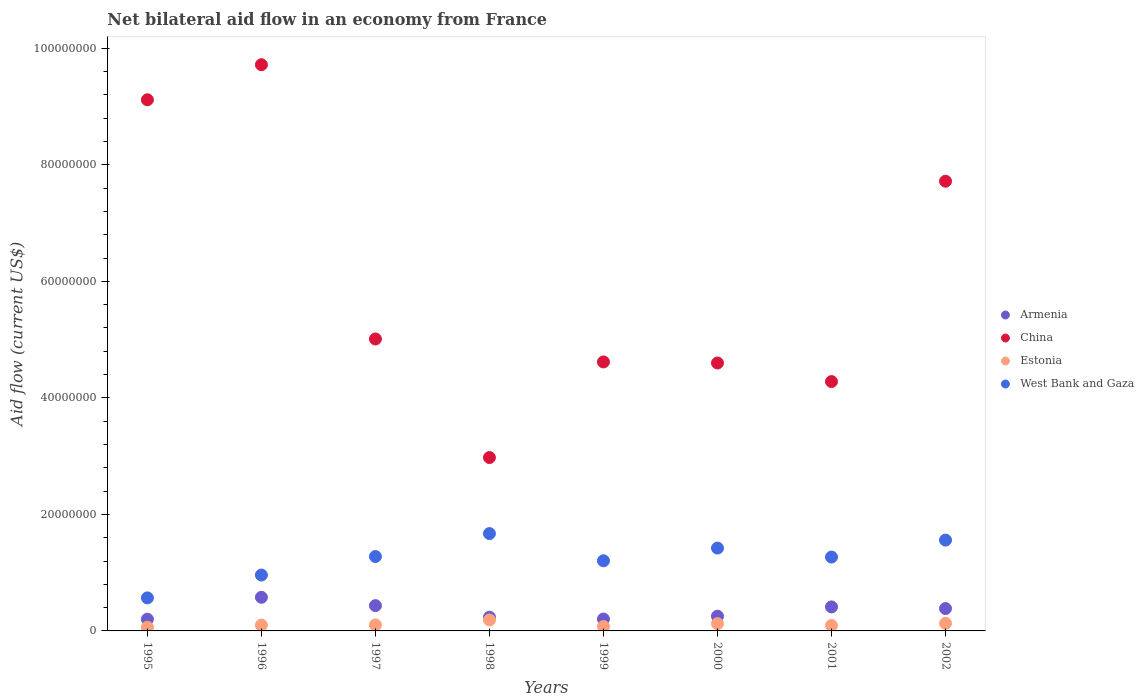How many different coloured dotlines are there?
Your answer should be very brief. 4. Is the number of dotlines equal to the number of legend labels?
Your answer should be very brief. Yes. What is the net bilateral aid flow in China in 1998?
Your answer should be very brief. 2.98e+07. Across all years, what is the maximum net bilateral aid flow in Estonia?
Your answer should be compact. 1.88e+06. Across all years, what is the minimum net bilateral aid flow in Armenia?
Give a very brief answer. 2.01e+06. In which year was the net bilateral aid flow in Armenia minimum?
Provide a short and direct response. 1995. What is the total net bilateral aid flow in Armenia in the graph?
Keep it short and to the point. 2.70e+07. What is the difference between the net bilateral aid flow in China in 1998 and that in 2001?
Offer a terse response. -1.30e+07. What is the difference between the net bilateral aid flow in West Bank and Gaza in 1995 and the net bilateral aid flow in China in 1999?
Keep it short and to the point. -4.05e+07. What is the average net bilateral aid flow in West Bank and Gaza per year?
Offer a terse response. 1.24e+07. In the year 1995, what is the difference between the net bilateral aid flow in West Bank and Gaza and net bilateral aid flow in Armenia?
Provide a short and direct response. 3.66e+06. What is the ratio of the net bilateral aid flow in Armenia in 1999 to that in 2002?
Offer a terse response. 0.53. Is the net bilateral aid flow in Armenia in 1999 less than that in 2002?
Offer a terse response. Yes. Is the difference between the net bilateral aid flow in West Bank and Gaza in 2000 and 2001 greater than the difference between the net bilateral aid flow in Armenia in 2000 and 2001?
Make the answer very short. Yes. What is the difference between the highest and the second highest net bilateral aid flow in China?
Your answer should be compact. 6.02e+06. What is the difference between the highest and the lowest net bilateral aid flow in West Bank and Gaza?
Your answer should be compact. 1.10e+07. Is it the case that in every year, the sum of the net bilateral aid flow in China and net bilateral aid flow in Estonia  is greater than the sum of net bilateral aid flow in Armenia and net bilateral aid flow in West Bank and Gaza?
Ensure brevity in your answer.  Yes. Is it the case that in every year, the sum of the net bilateral aid flow in Estonia and net bilateral aid flow in West Bank and Gaza  is greater than the net bilateral aid flow in China?
Make the answer very short. No. Is the net bilateral aid flow in Armenia strictly greater than the net bilateral aid flow in West Bank and Gaza over the years?
Your answer should be very brief. No. How many years are there in the graph?
Your answer should be very brief. 8. Are the values on the major ticks of Y-axis written in scientific E-notation?
Offer a terse response. No. Does the graph contain any zero values?
Your response must be concise. No. Does the graph contain grids?
Offer a terse response. No. How many legend labels are there?
Provide a succinct answer. 4. How are the legend labels stacked?
Your answer should be very brief. Vertical. What is the title of the graph?
Give a very brief answer. Net bilateral aid flow in an economy from France. What is the Aid flow (current US$) in Armenia in 1995?
Offer a terse response. 2.01e+06. What is the Aid flow (current US$) in China in 1995?
Make the answer very short. 9.12e+07. What is the Aid flow (current US$) of Estonia in 1995?
Provide a succinct answer. 6.30e+05. What is the Aid flow (current US$) of West Bank and Gaza in 1995?
Ensure brevity in your answer.  5.67e+06. What is the Aid flow (current US$) in Armenia in 1996?
Your response must be concise. 5.77e+06. What is the Aid flow (current US$) in China in 1996?
Give a very brief answer. 9.72e+07. What is the Aid flow (current US$) of West Bank and Gaza in 1996?
Make the answer very short. 9.59e+06. What is the Aid flow (current US$) of Armenia in 1997?
Your response must be concise. 4.34e+06. What is the Aid flow (current US$) of China in 1997?
Ensure brevity in your answer.  5.01e+07. What is the Aid flow (current US$) of Estonia in 1997?
Provide a succinct answer. 1.03e+06. What is the Aid flow (current US$) in West Bank and Gaza in 1997?
Make the answer very short. 1.28e+07. What is the Aid flow (current US$) of Armenia in 1998?
Your answer should be compact. 2.36e+06. What is the Aid flow (current US$) of China in 1998?
Provide a short and direct response. 2.98e+07. What is the Aid flow (current US$) in Estonia in 1998?
Offer a very short reply. 1.88e+06. What is the Aid flow (current US$) of West Bank and Gaza in 1998?
Ensure brevity in your answer.  1.67e+07. What is the Aid flow (current US$) in Armenia in 1999?
Keep it short and to the point. 2.04e+06. What is the Aid flow (current US$) of China in 1999?
Provide a short and direct response. 4.62e+07. What is the Aid flow (current US$) in Estonia in 1999?
Offer a terse response. 7.60e+05. What is the Aid flow (current US$) of West Bank and Gaza in 1999?
Keep it short and to the point. 1.20e+07. What is the Aid flow (current US$) of Armenia in 2000?
Offer a very short reply. 2.53e+06. What is the Aid flow (current US$) in China in 2000?
Your answer should be very brief. 4.60e+07. What is the Aid flow (current US$) of Estonia in 2000?
Provide a short and direct response. 1.25e+06. What is the Aid flow (current US$) in West Bank and Gaza in 2000?
Your answer should be compact. 1.42e+07. What is the Aid flow (current US$) of Armenia in 2001?
Your answer should be compact. 4.12e+06. What is the Aid flow (current US$) of China in 2001?
Provide a succinct answer. 4.28e+07. What is the Aid flow (current US$) in Estonia in 2001?
Your response must be concise. 9.40e+05. What is the Aid flow (current US$) in West Bank and Gaza in 2001?
Provide a succinct answer. 1.27e+07. What is the Aid flow (current US$) in Armenia in 2002?
Keep it short and to the point. 3.84e+06. What is the Aid flow (current US$) of China in 2002?
Provide a short and direct response. 7.72e+07. What is the Aid flow (current US$) of Estonia in 2002?
Your answer should be compact. 1.30e+06. What is the Aid flow (current US$) in West Bank and Gaza in 2002?
Your response must be concise. 1.56e+07. Across all years, what is the maximum Aid flow (current US$) in Armenia?
Your answer should be very brief. 5.77e+06. Across all years, what is the maximum Aid flow (current US$) in China?
Provide a succinct answer. 9.72e+07. Across all years, what is the maximum Aid flow (current US$) of Estonia?
Provide a succinct answer. 1.88e+06. Across all years, what is the maximum Aid flow (current US$) in West Bank and Gaza?
Keep it short and to the point. 1.67e+07. Across all years, what is the minimum Aid flow (current US$) of Armenia?
Offer a very short reply. 2.01e+06. Across all years, what is the minimum Aid flow (current US$) of China?
Keep it short and to the point. 2.98e+07. Across all years, what is the minimum Aid flow (current US$) in Estonia?
Offer a very short reply. 6.30e+05. Across all years, what is the minimum Aid flow (current US$) in West Bank and Gaza?
Your answer should be very brief. 5.67e+06. What is the total Aid flow (current US$) of Armenia in the graph?
Keep it short and to the point. 2.70e+07. What is the total Aid flow (current US$) of China in the graph?
Ensure brevity in your answer.  4.80e+08. What is the total Aid flow (current US$) of Estonia in the graph?
Your answer should be compact. 8.79e+06. What is the total Aid flow (current US$) in West Bank and Gaza in the graph?
Make the answer very short. 9.93e+07. What is the difference between the Aid flow (current US$) in Armenia in 1995 and that in 1996?
Ensure brevity in your answer.  -3.76e+06. What is the difference between the Aid flow (current US$) of China in 1995 and that in 1996?
Ensure brevity in your answer.  -6.02e+06. What is the difference between the Aid flow (current US$) in Estonia in 1995 and that in 1996?
Provide a succinct answer. -3.70e+05. What is the difference between the Aid flow (current US$) of West Bank and Gaza in 1995 and that in 1996?
Ensure brevity in your answer.  -3.92e+06. What is the difference between the Aid flow (current US$) of Armenia in 1995 and that in 1997?
Your response must be concise. -2.33e+06. What is the difference between the Aid flow (current US$) in China in 1995 and that in 1997?
Your answer should be very brief. 4.11e+07. What is the difference between the Aid flow (current US$) of Estonia in 1995 and that in 1997?
Offer a very short reply. -4.00e+05. What is the difference between the Aid flow (current US$) in West Bank and Gaza in 1995 and that in 1997?
Your response must be concise. -7.10e+06. What is the difference between the Aid flow (current US$) in Armenia in 1995 and that in 1998?
Your answer should be compact. -3.50e+05. What is the difference between the Aid flow (current US$) in China in 1995 and that in 1998?
Your answer should be very brief. 6.14e+07. What is the difference between the Aid flow (current US$) of Estonia in 1995 and that in 1998?
Your response must be concise. -1.25e+06. What is the difference between the Aid flow (current US$) in West Bank and Gaza in 1995 and that in 1998?
Offer a terse response. -1.10e+07. What is the difference between the Aid flow (current US$) in China in 1995 and that in 1999?
Give a very brief answer. 4.50e+07. What is the difference between the Aid flow (current US$) of Estonia in 1995 and that in 1999?
Ensure brevity in your answer.  -1.30e+05. What is the difference between the Aid flow (current US$) of West Bank and Gaza in 1995 and that in 1999?
Keep it short and to the point. -6.37e+06. What is the difference between the Aid flow (current US$) of Armenia in 1995 and that in 2000?
Provide a short and direct response. -5.20e+05. What is the difference between the Aid flow (current US$) of China in 1995 and that in 2000?
Ensure brevity in your answer.  4.52e+07. What is the difference between the Aid flow (current US$) in Estonia in 1995 and that in 2000?
Provide a short and direct response. -6.20e+05. What is the difference between the Aid flow (current US$) of West Bank and Gaza in 1995 and that in 2000?
Your response must be concise. -8.55e+06. What is the difference between the Aid flow (current US$) in Armenia in 1995 and that in 2001?
Your answer should be compact. -2.11e+06. What is the difference between the Aid flow (current US$) of China in 1995 and that in 2001?
Provide a short and direct response. 4.84e+07. What is the difference between the Aid flow (current US$) of Estonia in 1995 and that in 2001?
Your answer should be very brief. -3.10e+05. What is the difference between the Aid flow (current US$) in West Bank and Gaza in 1995 and that in 2001?
Your answer should be compact. -7.01e+06. What is the difference between the Aid flow (current US$) of Armenia in 1995 and that in 2002?
Offer a terse response. -1.83e+06. What is the difference between the Aid flow (current US$) of China in 1995 and that in 2002?
Offer a very short reply. 1.40e+07. What is the difference between the Aid flow (current US$) of Estonia in 1995 and that in 2002?
Provide a succinct answer. -6.70e+05. What is the difference between the Aid flow (current US$) in West Bank and Gaza in 1995 and that in 2002?
Your response must be concise. -9.92e+06. What is the difference between the Aid flow (current US$) in Armenia in 1996 and that in 1997?
Make the answer very short. 1.43e+06. What is the difference between the Aid flow (current US$) of China in 1996 and that in 1997?
Keep it short and to the point. 4.71e+07. What is the difference between the Aid flow (current US$) of West Bank and Gaza in 1996 and that in 1997?
Give a very brief answer. -3.18e+06. What is the difference between the Aid flow (current US$) of Armenia in 1996 and that in 1998?
Ensure brevity in your answer.  3.41e+06. What is the difference between the Aid flow (current US$) in China in 1996 and that in 1998?
Provide a short and direct response. 6.74e+07. What is the difference between the Aid flow (current US$) of Estonia in 1996 and that in 1998?
Your answer should be very brief. -8.80e+05. What is the difference between the Aid flow (current US$) in West Bank and Gaza in 1996 and that in 1998?
Provide a succinct answer. -7.12e+06. What is the difference between the Aid flow (current US$) of Armenia in 1996 and that in 1999?
Keep it short and to the point. 3.73e+06. What is the difference between the Aid flow (current US$) in China in 1996 and that in 1999?
Your answer should be compact. 5.10e+07. What is the difference between the Aid flow (current US$) in West Bank and Gaza in 1996 and that in 1999?
Your answer should be very brief. -2.45e+06. What is the difference between the Aid flow (current US$) in Armenia in 1996 and that in 2000?
Give a very brief answer. 3.24e+06. What is the difference between the Aid flow (current US$) of China in 1996 and that in 2000?
Give a very brief answer. 5.12e+07. What is the difference between the Aid flow (current US$) of West Bank and Gaza in 1996 and that in 2000?
Your answer should be compact. -4.63e+06. What is the difference between the Aid flow (current US$) of Armenia in 1996 and that in 2001?
Ensure brevity in your answer.  1.65e+06. What is the difference between the Aid flow (current US$) in China in 1996 and that in 2001?
Provide a short and direct response. 5.44e+07. What is the difference between the Aid flow (current US$) of West Bank and Gaza in 1996 and that in 2001?
Your answer should be very brief. -3.09e+06. What is the difference between the Aid flow (current US$) of Armenia in 1996 and that in 2002?
Provide a short and direct response. 1.93e+06. What is the difference between the Aid flow (current US$) in West Bank and Gaza in 1996 and that in 2002?
Give a very brief answer. -6.00e+06. What is the difference between the Aid flow (current US$) of Armenia in 1997 and that in 1998?
Make the answer very short. 1.98e+06. What is the difference between the Aid flow (current US$) in China in 1997 and that in 1998?
Your answer should be compact. 2.04e+07. What is the difference between the Aid flow (current US$) of Estonia in 1997 and that in 1998?
Provide a short and direct response. -8.50e+05. What is the difference between the Aid flow (current US$) in West Bank and Gaza in 1997 and that in 1998?
Offer a very short reply. -3.94e+06. What is the difference between the Aid flow (current US$) of Armenia in 1997 and that in 1999?
Your answer should be very brief. 2.30e+06. What is the difference between the Aid flow (current US$) in China in 1997 and that in 1999?
Your response must be concise. 3.94e+06. What is the difference between the Aid flow (current US$) of West Bank and Gaza in 1997 and that in 1999?
Offer a terse response. 7.30e+05. What is the difference between the Aid flow (current US$) of Armenia in 1997 and that in 2000?
Offer a very short reply. 1.81e+06. What is the difference between the Aid flow (current US$) of China in 1997 and that in 2000?
Give a very brief answer. 4.12e+06. What is the difference between the Aid flow (current US$) in West Bank and Gaza in 1997 and that in 2000?
Provide a short and direct response. -1.45e+06. What is the difference between the Aid flow (current US$) of China in 1997 and that in 2001?
Your response must be concise. 7.31e+06. What is the difference between the Aid flow (current US$) of Estonia in 1997 and that in 2001?
Provide a succinct answer. 9.00e+04. What is the difference between the Aid flow (current US$) in China in 1997 and that in 2002?
Your answer should be compact. -2.71e+07. What is the difference between the Aid flow (current US$) of Estonia in 1997 and that in 2002?
Offer a terse response. -2.70e+05. What is the difference between the Aid flow (current US$) of West Bank and Gaza in 1997 and that in 2002?
Offer a very short reply. -2.82e+06. What is the difference between the Aid flow (current US$) in Armenia in 1998 and that in 1999?
Your answer should be very brief. 3.20e+05. What is the difference between the Aid flow (current US$) in China in 1998 and that in 1999?
Provide a succinct answer. -1.64e+07. What is the difference between the Aid flow (current US$) of Estonia in 1998 and that in 1999?
Provide a short and direct response. 1.12e+06. What is the difference between the Aid flow (current US$) of West Bank and Gaza in 1998 and that in 1999?
Offer a terse response. 4.67e+06. What is the difference between the Aid flow (current US$) in Armenia in 1998 and that in 2000?
Provide a short and direct response. -1.70e+05. What is the difference between the Aid flow (current US$) of China in 1998 and that in 2000?
Offer a very short reply. -1.62e+07. What is the difference between the Aid flow (current US$) in Estonia in 1998 and that in 2000?
Your answer should be compact. 6.30e+05. What is the difference between the Aid flow (current US$) of West Bank and Gaza in 1998 and that in 2000?
Offer a terse response. 2.49e+06. What is the difference between the Aid flow (current US$) of Armenia in 1998 and that in 2001?
Your answer should be very brief. -1.76e+06. What is the difference between the Aid flow (current US$) of China in 1998 and that in 2001?
Keep it short and to the point. -1.30e+07. What is the difference between the Aid flow (current US$) in Estonia in 1998 and that in 2001?
Your response must be concise. 9.40e+05. What is the difference between the Aid flow (current US$) of West Bank and Gaza in 1998 and that in 2001?
Your answer should be compact. 4.03e+06. What is the difference between the Aid flow (current US$) in Armenia in 1998 and that in 2002?
Your answer should be compact. -1.48e+06. What is the difference between the Aid flow (current US$) of China in 1998 and that in 2002?
Your answer should be compact. -4.74e+07. What is the difference between the Aid flow (current US$) in Estonia in 1998 and that in 2002?
Your answer should be compact. 5.80e+05. What is the difference between the Aid flow (current US$) of West Bank and Gaza in 1998 and that in 2002?
Your response must be concise. 1.12e+06. What is the difference between the Aid flow (current US$) in Armenia in 1999 and that in 2000?
Make the answer very short. -4.90e+05. What is the difference between the Aid flow (current US$) in China in 1999 and that in 2000?
Your answer should be compact. 1.80e+05. What is the difference between the Aid flow (current US$) of Estonia in 1999 and that in 2000?
Ensure brevity in your answer.  -4.90e+05. What is the difference between the Aid flow (current US$) in West Bank and Gaza in 1999 and that in 2000?
Your response must be concise. -2.18e+06. What is the difference between the Aid flow (current US$) in Armenia in 1999 and that in 2001?
Offer a terse response. -2.08e+06. What is the difference between the Aid flow (current US$) in China in 1999 and that in 2001?
Offer a very short reply. 3.37e+06. What is the difference between the Aid flow (current US$) of Estonia in 1999 and that in 2001?
Your answer should be compact. -1.80e+05. What is the difference between the Aid flow (current US$) of West Bank and Gaza in 1999 and that in 2001?
Your answer should be compact. -6.40e+05. What is the difference between the Aid flow (current US$) of Armenia in 1999 and that in 2002?
Offer a terse response. -1.80e+06. What is the difference between the Aid flow (current US$) of China in 1999 and that in 2002?
Offer a very short reply. -3.10e+07. What is the difference between the Aid flow (current US$) in Estonia in 1999 and that in 2002?
Offer a very short reply. -5.40e+05. What is the difference between the Aid flow (current US$) of West Bank and Gaza in 1999 and that in 2002?
Ensure brevity in your answer.  -3.55e+06. What is the difference between the Aid flow (current US$) in Armenia in 2000 and that in 2001?
Provide a short and direct response. -1.59e+06. What is the difference between the Aid flow (current US$) in China in 2000 and that in 2001?
Your response must be concise. 3.19e+06. What is the difference between the Aid flow (current US$) in West Bank and Gaza in 2000 and that in 2001?
Offer a very short reply. 1.54e+06. What is the difference between the Aid flow (current US$) of Armenia in 2000 and that in 2002?
Provide a succinct answer. -1.31e+06. What is the difference between the Aid flow (current US$) in China in 2000 and that in 2002?
Give a very brief answer. -3.12e+07. What is the difference between the Aid flow (current US$) of West Bank and Gaza in 2000 and that in 2002?
Your response must be concise. -1.37e+06. What is the difference between the Aid flow (current US$) of Armenia in 2001 and that in 2002?
Ensure brevity in your answer.  2.80e+05. What is the difference between the Aid flow (current US$) in China in 2001 and that in 2002?
Keep it short and to the point. -3.44e+07. What is the difference between the Aid flow (current US$) of Estonia in 2001 and that in 2002?
Make the answer very short. -3.60e+05. What is the difference between the Aid flow (current US$) in West Bank and Gaza in 2001 and that in 2002?
Ensure brevity in your answer.  -2.91e+06. What is the difference between the Aid flow (current US$) of Armenia in 1995 and the Aid flow (current US$) of China in 1996?
Your response must be concise. -9.52e+07. What is the difference between the Aid flow (current US$) of Armenia in 1995 and the Aid flow (current US$) of Estonia in 1996?
Your answer should be compact. 1.01e+06. What is the difference between the Aid flow (current US$) of Armenia in 1995 and the Aid flow (current US$) of West Bank and Gaza in 1996?
Your answer should be compact. -7.58e+06. What is the difference between the Aid flow (current US$) of China in 1995 and the Aid flow (current US$) of Estonia in 1996?
Your response must be concise. 9.02e+07. What is the difference between the Aid flow (current US$) of China in 1995 and the Aid flow (current US$) of West Bank and Gaza in 1996?
Provide a succinct answer. 8.16e+07. What is the difference between the Aid flow (current US$) of Estonia in 1995 and the Aid flow (current US$) of West Bank and Gaza in 1996?
Keep it short and to the point. -8.96e+06. What is the difference between the Aid flow (current US$) of Armenia in 1995 and the Aid flow (current US$) of China in 1997?
Ensure brevity in your answer.  -4.81e+07. What is the difference between the Aid flow (current US$) of Armenia in 1995 and the Aid flow (current US$) of Estonia in 1997?
Your answer should be compact. 9.80e+05. What is the difference between the Aid flow (current US$) of Armenia in 1995 and the Aid flow (current US$) of West Bank and Gaza in 1997?
Your answer should be compact. -1.08e+07. What is the difference between the Aid flow (current US$) in China in 1995 and the Aid flow (current US$) in Estonia in 1997?
Provide a short and direct response. 9.01e+07. What is the difference between the Aid flow (current US$) of China in 1995 and the Aid flow (current US$) of West Bank and Gaza in 1997?
Keep it short and to the point. 7.84e+07. What is the difference between the Aid flow (current US$) of Estonia in 1995 and the Aid flow (current US$) of West Bank and Gaza in 1997?
Give a very brief answer. -1.21e+07. What is the difference between the Aid flow (current US$) in Armenia in 1995 and the Aid flow (current US$) in China in 1998?
Make the answer very short. -2.78e+07. What is the difference between the Aid flow (current US$) of Armenia in 1995 and the Aid flow (current US$) of Estonia in 1998?
Offer a terse response. 1.30e+05. What is the difference between the Aid flow (current US$) of Armenia in 1995 and the Aid flow (current US$) of West Bank and Gaza in 1998?
Make the answer very short. -1.47e+07. What is the difference between the Aid flow (current US$) of China in 1995 and the Aid flow (current US$) of Estonia in 1998?
Your answer should be very brief. 8.93e+07. What is the difference between the Aid flow (current US$) of China in 1995 and the Aid flow (current US$) of West Bank and Gaza in 1998?
Ensure brevity in your answer.  7.45e+07. What is the difference between the Aid flow (current US$) in Estonia in 1995 and the Aid flow (current US$) in West Bank and Gaza in 1998?
Make the answer very short. -1.61e+07. What is the difference between the Aid flow (current US$) in Armenia in 1995 and the Aid flow (current US$) in China in 1999?
Provide a short and direct response. -4.42e+07. What is the difference between the Aid flow (current US$) of Armenia in 1995 and the Aid flow (current US$) of Estonia in 1999?
Your response must be concise. 1.25e+06. What is the difference between the Aid flow (current US$) of Armenia in 1995 and the Aid flow (current US$) of West Bank and Gaza in 1999?
Give a very brief answer. -1.00e+07. What is the difference between the Aid flow (current US$) of China in 1995 and the Aid flow (current US$) of Estonia in 1999?
Ensure brevity in your answer.  9.04e+07. What is the difference between the Aid flow (current US$) in China in 1995 and the Aid flow (current US$) in West Bank and Gaza in 1999?
Ensure brevity in your answer.  7.91e+07. What is the difference between the Aid flow (current US$) of Estonia in 1995 and the Aid flow (current US$) of West Bank and Gaza in 1999?
Offer a very short reply. -1.14e+07. What is the difference between the Aid flow (current US$) in Armenia in 1995 and the Aid flow (current US$) in China in 2000?
Your response must be concise. -4.40e+07. What is the difference between the Aid flow (current US$) of Armenia in 1995 and the Aid flow (current US$) of Estonia in 2000?
Your answer should be compact. 7.60e+05. What is the difference between the Aid flow (current US$) in Armenia in 1995 and the Aid flow (current US$) in West Bank and Gaza in 2000?
Your response must be concise. -1.22e+07. What is the difference between the Aid flow (current US$) of China in 1995 and the Aid flow (current US$) of Estonia in 2000?
Keep it short and to the point. 8.99e+07. What is the difference between the Aid flow (current US$) of China in 1995 and the Aid flow (current US$) of West Bank and Gaza in 2000?
Ensure brevity in your answer.  7.70e+07. What is the difference between the Aid flow (current US$) in Estonia in 1995 and the Aid flow (current US$) in West Bank and Gaza in 2000?
Your answer should be compact. -1.36e+07. What is the difference between the Aid flow (current US$) of Armenia in 1995 and the Aid flow (current US$) of China in 2001?
Provide a succinct answer. -4.08e+07. What is the difference between the Aid flow (current US$) in Armenia in 1995 and the Aid flow (current US$) in Estonia in 2001?
Offer a very short reply. 1.07e+06. What is the difference between the Aid flow (current US$) in Armenia in 1995 and the Aid flow (current US$) in West Bank and Gaza in 2001?
Make the answer very short. -1.07e+07. What is the difference between the Aid flow (current US$) in China in 1995 and the Aid flow (current US$) in Estonia in 2001?
Provide a short and direct response. 9.02e+07. What is the difference between the Aid flow (current US$) in China in 1995 and the Aid flow (current US$) in West Bank and Gaza in 2001?
Offer a terse response. 7.85e+07. What is the difference between the Aid flow (current US$) of Estonia in 1995 and the Aid flow (current US$) of West Bank and Gaza in 2001?
Make the answer very short. -1.20e+07. What is the difference between the Aid flow (current US$) in Armenia in 1995 and the Aid flow (current US$) in China in 2002?
Provide a short and direct response. -7.52e+07. What is the difference between the Aid flow (current US$) in Armenia in 1995 and the Aid flow (current US$) in Estonia in 2002?
Give a very brief answer. 7.10e+05. What is the difference between the Aid flow (current US$) of Armenia in 1995 and the Aid flow (current US$) of West Bank and Gaza in 2002?
Provide a succinct answer. -1.36e+07. What is the difference between the Aid flow (current US$) in China in 1995 and the Aid flow (current US$) in Estonia in 2002?
Your answer should be very brief. 8.99e+07. What is the difference between the Aid flow (current US$) in China in 1995 and the Aid flow (current US$) in West Bank and Gaza in 2002?
Your answer should be very brief. 7.56e+07. What is the difference between the Aid flow (current US$) in Estonia in 1995 and the Aid flow (current US$) in West Bank and Gaza in 2002?
Provide a succinct answer. -1.50e+07. What is the difference between the Aid flow (current US$) of Armenia in 1996 and the Aid flow (current US$) of China in 1997?
Your answer should be compact. -4.43e+07. What is the difference between the Aid flow (current US$) of Armenia in 1996 and the Aid flow (current US$) of Estonia in 1997?
Ensure brevity in your answer.  4.74e+06. What is the difference between the Aid flow (current US$) in Armenia in 1996 and the Aid flow (current US$) in West Bank and Gaza in 1997?
Ensure brevity in your answer.  -7.00e+06. What is the difference between the Aid flow (current US$) of China in 1996 and the Aid flow (current US$) of Estonia in 1997?
Offer a very short reply. 9.62e+07. What is the difference between the Aid flow (current US$) in China in 1996 and the Aid flow (current US$) in West Bank and Gaza in 1997?
Give a very brief answer. 8.44e+07. What is the difference between the Aid flow (current US$) of Estonia in 1996 and the Aid flow (current US$) of West Bank and Gaza in 1997?
Give a very brief answer. -1.18e+07. What is the difference between the Aid flow (current US$) of Armenia in 1996 and the Aid flow (current US$) of China in 1998?
Your response must be concise. -2.40e+07. What is the difference between the Aid flow (current US$) in Armenia in 1996 and the Aid flow (current US$) in Estonia in 1998?
Give a very brief answer. 3.89e+06. What is the difference between the Aid flow (current US$) in Armenia in 1996 and the Aid flow (current US$) in West Bank and Gaza in 1998?
Your answer should be compact. -1.09e+07. What is the difference between the Aid flow (current US$) of China in 1996 and the Aid flow (current US$) of Estonia in 1998?
Offer a terse response. 9.53e+07. What is the difference between the Aid flow (current US$) in China in 1996 and the Aid flow (current US$) in West Bank and Gaza in 1998?
Keep it short and to the point. 8.05e+07. What is the difference between the Aid flow (current US$) in Estonia in 1996 and the Aid flow (current US$) in West Bank and Gaza in 1998?
Offer a very short reply. -1.57e+07. What is the difference between the Aid flow (current US$) in Armenia in 1996 and the Aid flow (current US$) in China in 1999?
Your response must be concise. -4.04e+07. What is the difference between the Aid flow (current US$) in Armenia in 1996 and the Aid flow (current US$) in Estonia in 1999?
Your answer should be compact. 5.01e+06. What is the difference between the Aid flow (current US$) in Armenia in 1996 and the Aid flow (current US$) in West Bank and Gaza in 1999?
Your response must be concise. -6.27e+06. What is the difference between the Aid flow (current US$) in China in 1996 and the Aid flow (current US$) in Estonia in 1999?
Make the answer very short. 9.64e+07. What is the difference between the Aid flow (current US$) in China in 1996 and the Aid flow (current US$) in West Bank and Gaza in 1999?
Offer a terse response. 8.52e+07. What is the difference between the Aid flow (current US$) in Estonia in 1996 and the Aid flow (current US$) in West Bank and Gaza in 1999?
Offer a very short reply. -1.10e+07. What is the difference between the Aid flow (current US$) in Armenia in 1996 and the Aid flow (current US$) in China in 2000?
Offer a very short reply. -4.02e+07. What is the difference between the Aid flow (current US$) in Armenia in 1996 and the Aid flow (current US$) in Estonia in 2000?
Offer a terse response. 4.52e+06. What is the difference between the Aid flow (current US$) of Armenia in 1996 and the Aid flow (current US$) of West Bank and Gaza in 2000?
Provide a succinct answer. -8.45e+06. What is the difference between the Aid flow (current US$) of China in 1996 and the Aid flow (current US$) of Estonia in 2000?
Your answer should be very brief. 9.59e+07. What is the difference between the Aid flow (current US$) of China in 1996 and the Aid flow (current US$) of West Bank and Gaza in 2000?
Your answer should be compact. 8.30e+07. What is the difference between the Aid flow (current US$) in Estonia in 1996 and the Aid flow (current US$) in West Bank and Gaza in 2000?
Ensure brevity in your answer.  -1.32e+07. What is the difference between the Aid flow (current US$) of Armenia in 1996 and the Aid flow (current US$) of China in 2001?
Your answer should be compact. -3.70e+07. What is the difference between the Aid flow (current US$) of Armenia in 1996 and the Aid flow (current US$) of Estonia in 2001?
Provide a short and direct response. 4.83e+06. What is the difference between the Aid flow (current US$) of Armenia in 1996 and the Aid flow (current US$) of West Bank and Gaza in 2001?
Ensure brevity in your answer.  -6.91e+06. What is the difference between the Aid flow (current US$) of China in 1996 and the Aid flow (current US$) of Estonia in 2001?
Ensure brevity in your answer.  9.62e+07. What is the difference between the Aid flow (current US$) of China in 1996 and the Aid flow (current US$) of West Bank and Gaza in 2001?
Provide a short and direct response. 8.45e+07. What is the difference between the Aid flow (current US$) in Estonia in 1996 and the Aid flow (current US$) in West Bank and Gaza in 2001?
Make the answer very short. -1.17e+07. What is the difference between the Aid flow (current US$) in Armenia in 1996 and the Aid flow (current US$) in China in 2002?
Give a very brief answer. -7.14e+07. What is the difference between the Aid flow (current US$) of Armenia in 1996 and the Aid flow (current US$) of Estonia in 2002?
Keep it short and to the point. 4.47e+06. What is the difference between the Aid flow (current US$) in Armenia in 1996 and the Aid flow (current US$) in West Bank and Gaza in 2002?
Ensure brevity in your answer.  -9.82e+06. What is the difference between the Aid flow (current US$) of China in 1996 and the Aid flow (current US$) of Estonia in 2002?
Your answer should be very brief. 9.59e+07. What is the difference between the Aid flow (current US$) in China in 1996 and the Aid flow (current US$) in West Bank and Gaza in 2002?
Provide a short and direct response. 8.16e+07. What is the difference between the Aid flow (current US$) of Estonia in 1996 and the Aid flow (current US$) of West Bank and Gaza in 2002?
Ensure brevity in your answer.  -1.46e+07. What is the difference between the Aid flow (current US$) of Armenia in 1997 and the Aid flow (current US$) of China in 1998?
Offer a terse response. -2.54e+07. What is the difference between the Aid flow (current US$) of Armenia in 1997 and the Aid flow (current US$) of Estonia in 1998?
Ensure brevity in your answer.  2.46e+06. What is the difference between the Aid flow (current US$) of Armenia in 1997 and the Aid flow (current US$) of West Bank and Gaza in 1998?
Your answer should be very brief. -1.24e+07. What is the difference between the Aid flow (current US$) of China in 1997 and the Aid flow (current US$) of Estonia in 1998?
Your answer should be compact. 4.82e+07. What is the difference between the Aid flow (current US$) of China in 1997 and the Aid flow (current US$) of West Bank and Gaza in 1998?
Keep it short and to the point. 3.34e+07. What is the difference between the Aid flow (current US$) of Estonia in 1997 and the Aid flow (current US$) of West Bank and Gaza in 1998?
Provide a short and direct response. -1.57e+07. What is the difference between the Aid flow (current US$) of Armenia in 1997 and the Aid flow (current US$) of China in 1999?
Your answer should be very brief. -4.18e+07. What is the difference between the Aid flow (current US$) in Armenia in 1997 and the Aid flow (current US$) in Estonia in 1999?
Keep it short and to the point. 3.58e+06. What is the difference between the Aid flow (current US$) in Armenia in 1997 and the Aid flow (current US$) in West Bank and Gaza in 1999?
Make the answer very short. -7.70e+06. What is the difference between the Aid flow (current US$) of China in 1997 and the Aid flow (current US$) of Estonia in 1999?
Keep it short and to the point. 4.94e+07. What is the difference between the Aid flow (current US$) of China in 1997 and the Aid flow (current US$) of West Bank and Gaza in 1999?
Make the answer very short. 3.81e+07. What is the difference between the Aid flow (current US$) in Estonia in 1997 and the Aid flow (current US$) in West Bank and Gaza in 1999?
Keep it short and to the point. -1.10e+07. What is the difference between the Aid flow (current US$) of Armenia in 1997 and the Aid flow (current US$) of China in 2000?
Offer a terse response. -4.16e+07. What is the difference between the Aid flow (current US$) of Armenia in 1997 and the Aid flow (current US$) of Estonia in 2000?
Provide a short and direct response. 3.09e+06. What is the difference between the Aid flow (current US$) in Armenia in 1997 and the Aid flow (current US$) in West Bank and Gaza in 2000?
Keep it short and to the point. -9.88e+06. What is the difference between the Aid flow (current US$) of China in 1997 and the Aid flow (current US$) of Estonia in 2000?
Ensure brevity in your answer.  4.89e+07. What is the difference between the Aid flow (current US$) in China in 1997 and the Aid flow (current US$) in West Bank and Gaza in 2000?
Your answer should be compact. 3.59e+07. What is the difference between the Aid flow (current US$) of Estonia in 1997 and the Aid flow (current US$) of West Bank and Gaza in 2000?
Make the answer very short. -1.32e+07. What is the difference between the Aid flow (current US$) of Armenia in 1997 and the Aid flow (current US$) of China in 2001?
Your answer should be very brief. -3.85e+07. What is the difference between the Aid flow (current US$) in Armenia in 1997 and the Aid flow (current US$) in Estonia in 2001?
Make the answer very short. 3.40e+06. What is the difference between the Aid flow (current US$) in Armenia in 1997 and the Aid flow (current US$) in West Bank and Gaza in 2001?
Your answer should be compact. -8.34e+06. What is the difference between the Aid flow (current US$) in China in 1997 and the Aid flow (current US$) in Estonia in 2001?
Ensure brevity in your answer.  4.92e+07. What is the difference between the Aid flow (current US$) in China in 1997 and the Aid flow (current US$) in West Bank and Gaza in 2001?
Ensure brevity in your answer.  3.74e+07. What is the difference between the Aid flow (current US$) in Estonia in 1997 and the Aid flow (current US$) in West Bank and Gaza in 2001?
Your answer should be compact. -1.16e+07. What is the difference between the Aid flow (current US$) in Armenia in 1997 and the Aid flow (current US$) in China in 2002?
Offer a terse response. -7.28e+07. What is the difference between the Aid flow (current US$) in Armenia in 1997 and the Aid flow (current US$) in Estonia in 2002?
Offer a terse response. 3.04e+06. What is the difference between the Aid flow (current US$) in Armenia in 1997 and the Aid flow (current US$) in West Bank and Gaza in 2002?
Make the answer very short. -1.12e+07. What is the difference between the Aid flow (current US$) in China in 1997 and the Aid flow (current US$) in Estonia in 2002?
Your answer should be compact. 4.88e+07. What is the difference between the Aid flow (current US$) of China in 1997 and the Aid flow (current US$) of West Bank and Gaza in 2002?
Make the answer very short. 3.45e+07. What is the difference between the Aid flow (current US$) of Estonia in 1997 and the Aid flow (current US$) of West Bank and Gaza in 2002?
Keep it short and to the point. -1.46e+07. What is the difference between the Aid flow (current US$) of Armenia in 1998 and the Aid flow (current US$) of China in 1999?
Your response must be concise. -4.38e+07. What is the difference between the Aid flow (current US$) in Armenia in 1998 and the Aid flow (current US$) in Estonia in 1999?
Your answer should be very brief. 1.60e+06. What is the difference between the Aid flow (current US$) in Armenia in 1998 and the Aid flow (current US$) in West Bank and Gaza in 1999?
Provide a succinct answer. -9.68e+06. What is the difference between the Aid flow (current US$) of China in 1998 and the Aid flow (current US$) of Estonia in 1999?
Ensure brevity in your answer.  2.90e+07. What is the difference between the Aid flow (current US$) in China in 1998 and the Aid flow (current US$) in West Bank and Gaza in 1999?
Your answer should be compact. 1.77e+07. What is the difference between the Aid flow (current US$) of Estonia in 1998 and the Aid flow (current US$) of West Bank and Gaza in 1999?
Your answer should be very brief. -1.02e+07. What is the difference between the Aid flow (current US$) of Armenia in 1998 and the Aid flow (current US$) of China in 2000?
Give a very brief answer. -4.36e+07. What is the difference between the Aid flow (current US$) in Armenia in 1998 and the Aid flow (current US$) in Estonia in 2000?
Your answer should be compact. 1.11e+06. What is the difference between the Aid flow (current US$) of Armenia in 1998 and the Aid flow (current US$) of West Bank and Gaza in 2000?
Ensure brevity in your answer.  -1.19e+07. What is the difference between the Aid flow (current US$) of China in 1998 and the Aid flow (current US$) of Estonia in 2000?
Your answer should be very brief. 2.85e+07. What is the difference between the Aid flow (current US$) in China in 1998 and the Aid flow (current US$) in West Bank and Gaza in 2000?
Give a very brief answer. 1.55e+07. What is the difference between the Aid flow (current US$) in Estonia in 1998 and the Aid flow (current US$) in West Bank and Gaza in 2000?
Your response must be concise. -1.23e+07. What is the difference between the Aid flow (current US$) of Armenia in 1998 and the Aid flow (current US$) of China in 2001?
Your answer should be very brief. -4.04e+07. What is the difference between the Aid flow (current US$) of Armenia in 1998 and the Aid flow (current US$) of Estonia in 2001?
Offer a very short reply. 1.42e+06. What is the difference between the Aid flow (current US$) of Armenia in 1998 and the Aid flow (current US$) of West Bank and Gaza in 2001?
Offer a terse response. -1.03e+07. What is the difference between the Aid flow (current US$) of China in 1998 and the Aid flow (current US$) of Estonia in 2001?
Provide a succinct answer. 2.88e+07. What is the difference between the Aid flow (current US$) of China in 1998 and the Aid flow (current US$) of West Bank and Gaza in 2001?
Ensure brevity in your answer.  1.71e+07. What is the difference between the Aid flow (current US$) of Estonia in 1998 and the Aid flow (current US$) of West Bank and Gaza in 2001?
Ensure brevity in your answer.  -1.08e+07. What is the difference between the Aid flow (current US$) in Armenia in 1998 and the Aid flow (current US$) in China in 2002?
Ensure brevity in your answer.  -7.48e+07. What is the difference between the Aid flow (current US$) in Armenia in 1998 and the Aid flow (current US$) in Estonia in 2002?
Make the answer very short. 1.06e+06. What is the difference between the Aid flow (current US$) in Armenia in 1998 and the Aid flow (current US$) in West Bank and Gaza in 2002?
Offer a very short reply. -1.32e+07. What is the difference between the Aid flow (current US$) of China in 1998 and the Aid flow (current US$) of Estonia in 2002?
Ensure brevity in your answer.  2.85e+07. What is the difference between the Aid flow (current US$) in China in 1998 and the Aid flow (current US$) in West Bank and Gaza in 2002?
Give a very brief answer. 1.42e+07. What is the difference between the Aid flow (current US$) of Estonia in 1998 and the Aid flow (current US$) of West Bank and Gaza in 2002?
Provide a short and direct response. -1.37e+07. What is the difference between the Aid flow (current US$) of Armenia in 1999 and the Aid flow (current US$) of China in 2000?
Keep it short and to the point. -4.40e+07. What is the difference between the Aid flow (current US$) in Armenia in 1999 and the Aid flow (current US$) in Estonia in 2000?
Provide a short and direct response. 7.90e+05. What is the difference between the Aid flow (current US$) in Armenia in 1999 and the Aid flow (current US$) in West Bank and Gaza in 2000?
Your answer should be very brief. -1.22e+07. What is the difference between the Aid flow (current US$) of China in 1999 and the Aid flow (current US$) of Estonia in 2000?
Provide a succinct answer. 4.49e+07. What is the difference between the Aid flow (current US$) of China in 1999 and the Aid flow (current US$) of West Bank and Gaza in 2000?
Give a very brief answer. 3.20e+07. What is the difference between the Aid flow (current US$) of Estonia in 1999 and the Aid flow (current US$) of West Bank and Gaza in 2000?
Keep it short and to the point. -1.35e+07. What is the difference between the Aid flow (current US$) in Armenia in 1999 and the Aid flow (current US$) in China in 2001?
Keep it short and to the point. -4.08e+07. What is the difference between the Aid flow (current US$) in Armenia in 1999 and the Aid flow (current US$) in Estonia in 2001?
Provide a short and direct response. 1.10e+06. What is the difference between the Aid flow (current US$) of Armenia in 1999 and the Aid flow (current US$) of West Bank and Gaza in 2001?
Offer a very short reply. -1.06e+07. What is the difference between the Aid flow (current US$) of China in 1999 and the Aid flow (current US$) of Estonia in 2001?
Your answer should be compact. 4.52e+07. What is the difference between the Aid flow (current US$) in China in 1999 and the Aid flow (current US$) in West Bank and Gaza in 2001?
Offer a very short reply. 3.35e+07. What is the difference between the Aid flow (current US$) of Estonia in 1999 and the Aid flow (current US$) of West Bank and Gaza in 2001?
Ensure brevity in your answer.  -1.19e+07. What is the difference between the Aid flow (current US$) of Armenia in 1999 and the Aid flow (current US$) of China in 2002?
Your answer should be very brief. -7.52e+07. What is the difference between the Aid flow (current US$) in Armenia in 1999 and the Aid flow (current US$) in Estonia in 2002?
Provide a short and direct response. 7.40e+05. What is the difference between the Aid flow (current US$) of Armenia in 1999 and the Aid flow (current US$) of West Bank and Gaza in 2002?
Keep it short and to the point. -1.36e+07. What is the difference between the Aid flow (current US$) of China in 1999 and the Aid flow (current US$) of Estonia in 2002?
Your response must be concise. 4.49e+07. What is the difference between the Aid flow (current US$) in China in 1999 and the Aid flow (current US$) in West Bank and Gaza in 2002?
Your answer should be compact. 3.06e+07. What is the difference between the Aid flow (current US$) of Estonia in 1999 and the Aid flow (current US$) of West Bank and Gaza in 2002?
Your answer should be compact. -1.48e+07. What is the difference between the Aid flow (current US$) of Armenia in 2000 and the Aid flow (current US$) of China in 2001?
Provide a succinct answer. -4.03e+07. What is the difference between the Aid flow (current US$) of Armenia in 2000 and the Aid flow (current US$) of Estonia in 2001?
Offer a very short reply. 1.59e+06. What is the difference between the Aid flow (current US$) in Armenia in 2000 and the Aid flow (current US$) in West Bank and Gaza in 2001?
Provide a short and direct response. -1.02e+07. What is the difference between the Aid flow (current US$) of China in 2000 and the Aid flow (current US$) of Estonia in 2001?
Give a very brief answer. 4.50e+07. What is the difference between the Aid flow (current US$) in China in 2000 and the Aid flow (current US$) in West Bank and Gaza in 2001?
Offer a terse response. 3.33e+07. What is the difference between the Aid flow (current US$) of Estonia in 2000 and the Aid flow (current US$) of West Bank and Gaza in 2001?
Provide a succinct answer. -1.14e+07. What is the difference between the Aid flow (current US$) of Armenia in 2000 and the Aid flow (current US$) of China in 2002?
Make the answer very short. -7.47e+07. What is the difference between the Aid flow (current US$) in Armenia in 2000 and the Aid flow (current US$) in Estonia in 2002?
Your answer should be compact. 1.23e+06. What is the difference between the Aid flow (current US$) in Armenia in 2000 and the Aid flow (current US$) in West Bank and Gaza in 2002?
Make the answer very short. -1.31e+07. What is the difference between the Aid flow (current US$) of China in 2000 and the Aid flow (current US$) of Estonia in 2002?
Provide a succinct answer. 4.47e+07. What is the difference between the Aid flow (current US$) of China in 2000 and the Aid flow (current US$) of West Bank and Gaza in 2002?
Your answer should be very brief. 3.04e+07. What is the difference between the Aid flow (current US$) in Estonia in 2000 and the Aid flow (current US$) in West Bank and Gaza in 2002?
Keep it short and to the point. -1.43e+07. What is the difference between the Aid flow (current US$) of Armenia in 2001 and the Aid flow (current US$) of China in 2002?
Make the answer very short. -7.31e+07. What is the difference between the Aid flow (current US$) in Armenia in 2001 and the Aid flow (current US$) in Estonia in 2002?
Provide a succinct answer. 2.82e+06. What is the difference between the Aid flow (current US$) in Armenia in 2001 and the Aid flow (current US$) in West Bank and Gaza in 2002?
Offer a terse response. -1.15e+07. What is the difference between the Aid flow (current US$) in China in 2001 and the Aid flow (current US$) in Estonia in 2002?
Provide a short and direct response. 4.15e+07. What is the difference between the Aid flow (current US$) of China in 2001 and the Aid flow (current US$) of West Bank and Gaza in 2002?
Give a very brief answer. 2.72e+07. What is the difference between the Aid flow (current US$) in Estonia in 2001 and the Aid flow (current US$) in West Bank and Gaza in 2002?
Your response must be concise. -1.46e+07. What is the average Aid flow (current US$) in Armenia per year?
Your response must be concise. 3.38e+06. What is the average Aid flow (current US$) of China per year?
Give a very brief answer. 6.00e+07. What is the average Aid flow (current US$) of Estonia per year?
Ensure brevity in your answer.  1.10e+06. What is the average Aid flow (current US$) of West Bank and Gaza per year?
Your answer should be compact. 1.24e+07. In the year 1995, what is the difference between the Aid flow (current US$) of Armenia and Aid flow (current US$) of China?
Offer a terse response. -8.92e+07. In the year 1995, what is the difference between the Aid flow (current US$) in Armenia and Aid flow (current US$) in Estonia?
Provide a short and direct response. 1.38e+06. In the year 1995, what is the difference between the Aid flow (current US$) of Armenia and Aid flow (current US$) of West Bank and Gaza?
Keep it short and to the point. -3.66e+06. In the year 1995, what is the difference between the Aid flow (current US$) of China and Aid flow (current US$) of Estonia?
Your response must be concise. 9.05e+07. In the year 1995, what is the difference between the Aid flow (current US$) of China and Aid flow (current US$) of West Bank and Gaza?
Offer a terse response. 8.55e+07. In the year 1995, what is the difference between the Aid flow (current US$) of Estonia and Aid flow (current US$) of West Bank and Gaza?
Give a very brief answer. -5.04e+06. In the year 1996, what is the difference between the Aid flow (current US$) of Armenia and Aid flow (current US$) of China?
Make the answer very short. -9.14e+07. In the year 1996, what is the difference between the Aid flow (current US$) in Armenia and Aid flow (current US$) in Estonia?
Provide a short and direct response. 4.77e+06. In the year 1996, what is the difference between the Aid flow (current US$) in Armenia and Aid flow (current US$) in West Bank and Gaza?
Keep it short and to the point. -3.82e+06. In the year 1996, what is the difference between the Aid flow (current US$) in China and Aid flow (current US$) in Estonia?
Ensure brevity in your answer.  9.62e+07. In the year 1996, what is the difference between the Aid flow (current US$) of China and Aid flow (current US$) of West Bank and Gaza?
Make the answer very short. 8.76e+07. In the year 1996, what is the difference between the Aid flow (current US$) of Estonia and Aid flow (current US$) of West Bank and Gaza?
Provide a short and direct response. -8.59e+06. In the year 1997, what is the difference between the Aid flow (current US$) in Armenia and Aid flow (current US$) in China?
Your response must be concise. -4.58e+07. In the year 1997, what is the difference between the Aid flow (current US$) of Armenia and Aid flow (current US$) of Estonia?
Give a very brief answer. 3.31e+06. In the year 1997, what is the difference between the Aid flow (current US$) in Armenia and Aid flow (current US$) in West Bank and Gaza?
Provide a succinct answer. -8.43e+06. In the year 1997, what is the difference between the Aid flow (current US$) of China and Aid flow (current US$) of Estonia?
Your answer should be compact. 4.91e+07. In the year 1997, what is the difference between the Aid flow (current US$) of China and Aid flow (current US$) of West Bank and Gaza?
Give a very brief answer. 3.73e+07. In the year 1997, what is the difference between the Aid flow (current US$) in Estonia and Aid flow (current US$) in West Bank and Gaza?
Your answer should be very brief. -1.17e+07. In the year 1998, what is the difference between the Aid flow (current US$) of Armenia and Aid flow (current US$) of China?
Provide a succinct answer. -2.74e+07. In the year 1998, what is the difference between the Aid flow (current US$) of Armenia and Aid flow (current US$) of West Bank and Gaza?
Your answer should be compact. -1.44e+07. In the year 1998, what is the difference between the Aid flow (current US$) of China and Aid flow (current US$) of Estonia?
Make the answer very short. 2.79e+07. In the year 1998, what is the difference between the Aid flow (current US$) in China and Aid flow (current US$) in West Bank and Gaza?
Offer a terse response. 1.30e+07. In the year 1998, what is the difference between the Aid flow (current US$) in Estonia and Aid flow (current US$) in West Bank and Gaza?
Offer a terse response. -1.48e+07. In the year 1999, what is the difference between the Aid flow (current US$) of Armenia and Aid flow (current US$) of China?
Ensure brevity in your answer.  -4.41e+07. In the year 1999, what is the difference between the Aid flow (current US$) of Armenia and Aid flow (current US$) of Estonia?
Provide a short and direct response. 1.28e+06. In the year 1999, what is the difference between the Aid flow (current US$) in Armenia and Aid flow (current US$) in West Bank and Gaza?
Ensure brevity in your answer.  -1.00e+07. In the year 1999, what is the difference between the Aid flow (current US$) in China and Aid flow (current US$) in Estonia?
Offer a terse response. 4.54e+07. In the year 1999, what is the difference between the Aid flow (current US$) of China and Aid flow (current US$) of West Bank and Gaza?
Keep it short and to the point. 3.41e+07. In the year 1999, what is the difference between the Aid flow (current US$) in Estonia and Aid flow (current US$) in West Bank and Gaza?
Provide a succinct answer. -1.13e+07. In the year 2000, what is the difference between the Aid flow (current US$) of Armenia and Aid flow (current US$) of China?
Give a very brief answer. -4.35e+07. In the year 2000, what is the difference between the Aid flow (current US$) in Armenia and Aid flow (current US$) in Estonia?
Offer a terse response. 1.28e+06. In the year 2000, what is the difference between the Aid flow (current US$) of Armenia and Aid flow (current US$) of West Bank and Gaza?
Ensure brevity in your answer.  -1.17e+07. In the year 2000, what is the difference between the Aid flow (current US$) in China and Aid flow (current US$) in Estonia?
Your answer should be compact. 4.47e+07. In the year 2000, what is the difference between the Aid flow (current US$) of China and Aid flow (current US$) of West Bank and Gaza?
Provide a short and direct response. 3.18e+07. In the year 2000, what is the difference between the Aid flow (current US$) of Estonia and Aid flow (current US$) of West Bank and Gaza?
Your answer should be compact. -1.30e+07. In the year 2001, what is the difference between the Aid flow (current US$) in Armenia and Aid flow (current US$) in China?
Keep it short and to the point. -3.87e+07. In the year 2001, what is the difference between the Aid flow (current US$) in Armenia and Aid flow (current US$) in Estonia?
Offer a very short reply. 3.18e+06. In the year 2001, what is the difference between the Aid flow (current US$) in Armenia and Aid flow (current US$) in West Bank and Gaza?
Keep it short and to the point. -8.56e+06. In the year 2001, what is the difference between the Aid flow (current US$) in China and Aid flow (current US$) in Estonia?
Give a very brief answer. 4.19e+07. In the year 2001, what is the difference between the Aid flow (current US$) of China and Aid flow (current US$) of West Bank and Gaza?
Make the answer very short. 3.01e+07. In the year 2001, what is the difference between the Aid flow (current US$) of Estonia and Aid flow (current US$) of West Bank and Gaza?
Ensure brevity in your answer.  -1.17e+07. In the year 2002, what is the difference between the Aid flow (current US$) in Armenia and Aid flow (current US$) in China?
Keep it short and to the point. -7.34e+07. In the year 2002, what is the difference between the Aid flow (current US$) of Armenia and Aid flow (current US$) of Estonia?
Keep it short and to the point. 2.54e+06. In the year 2002, what is the difference between the Aid flow (current US$) of Armenia and Aid flow (current US$) of West Bank and Gaza?
Provide a succinct answer. -1.18e+07. In the year 2002, what is the difference between the Aid flow (current US$) in China and Aid flow (current US$) in Estonia?
Provide a short and direct response. 7.59e+07. In the year 2002, what is the difference between the Aid flow (current US$) of China and Aid flow (current US$) of West Bank and Gaza?
Offer a terse response. 6.16e+07. In the year 2002, what is the difference between the Aid flow (current US$) of Estonia and Aid flow (current US$) of West Bank and Gaza?
Ensure brevity in your answer.  -1.43e+07. What is the ratio of the Aid flow (current US$) of Armenia in 1995 to that in 1996?
Ensure brevity in your answer.  0.35. What is the ratio of the Aid flow (current US$) of China in 1995 to that in 1996?
Keep it short and to the point. 0.94. What is the ratio of the Aid flow (current US$) in Estonia in 1995 to that in 1996?
Provide a succinct answer. 0.63. What is the ratio of the Aid flow (current US$) in West Bank and Gaza in 1995 to that in 1996?
Your response must be concise. 0.59. What is the ratio of the Aid flow (current US$) of Armenia in 1995 to that in 1997?
Offer a very short reply. 0.46. What is the ratio of the Aid flow (current US$) in China in 1995 to that in 1997?
Offer a very short reply. 1.82. What is the ratio of the Aid flow (current US$) in Estonia in 1995 to that in 1997?
Provide a short and direct response. 0.61. What is the ratio of the Aid flow (current US$) of West Bank and Gaza in 1995 to that in 1997?
Your answer should be compact. 0.44. What is the ratio of the Aid flow (current US$) of Armenia in 1995 to that in 1998?
Give a very brief answer. 0.85. What is the ratio of the Aid flow (current US$) of China in 1995 to that in 1998?
Your response must be concise. 3.06. What is the ratio of the Aid flow (current US$) in Estonia in 1995 to that in 1998?
Offer a very short reply. 0.34. What is the ratio of the Aid flow (current US$) of West Bank and Gaza in 1995 to that in 1998?
Give a very brief answer. 0.34. What is the ratio of the Aid flow (current US$) in China in 1995 to that in 1999?
Offer a very short reply. 1.97. What is the ratio of the Aid flow (current US$) in Estonia in 1995 to that in 1999?
Your answer should be compact. 0.83. What is the ratio of the Aid flow (current US$) of West Bank and Gaza in 1995 to that in 1999?
Your response must be concise. 0.47. What is the ratio of the Aid flow (current US$) in Armenia in 1995 to that in 2000?
Make the answer very short. 0.79. What is the ratio of the Aid flow (current US$) of China in 1995 to that in 2000?
Offer a very short reply. 1.98. What is the ratio of the Aid flow (current US$) in Estonia in 1995 to that in 2000?
Make the answer very short. 0.5. What is the ratio of the Aid flow (current US$) in West Bank and Gaza in 1995 to that in 2000?
Provide a succinct answer. 0.4. What is the ratio of the Aid flow (current US$) in Armenia in 1995 to that in 2001?
Your response must be concise. 0.49. What is the ratio of the Aid flow (current US$) of China in 1995 to that in 2001?
Provide a short and direct response. 2.13. What is the ratio of the Aid flow (current US$) of Estonia in 1995 to that in 2001?
Provide a short and direct response. 0.67. What is the ratio of the Aid flow (current US$) in West Bank and Gaza in 1995 to that in 2001?
Provide a short and direct response. 0.45. What is the ratio of the Aid flow (current US$) in Armenia in 1995 to that in 2002?
Provide a short and direct response. 0.52. What is the ratio of the Aid flow (current US$) in China in 1995 to that in 2002?
Offer a very short reply. 1.18. What is the ratio of the Aid flow (current US$) in Estonia in 1995 to that in 2002?
Provide a short and direct response. 0.48. What is the ratio of the Aid flow (current US$) in West Bank and Gaza in 1995 to that in 2002?
Ensure brevity in your answer.  0.36. What is the ratio of the Aid flow (current US$) of Armenia in 1996 to that in 1997?
Your response must be concise. 1.33. What is the ratio of the Aid flow (current US$) in China in 1996 to that in 1997?
Your response must be concise. 1.94. What is the ratio of the Aid flow (current US$) of Estonia in 1996 to that in 1997?
Your answer should be compact. 0.97. What is the ratio of the Aid flow (current US$) of West Bank and Gaza in 1996 to that in 1997?
Provide a short and direct response. 0.75. What is the ratio of the Aid flow (current US$) in Armenia in 1996 to that in 1998?
Your answer should be very brief. 2.44. What is the ratio of the Aid flow (current US$) in China in 1996 to that in 1998?
Offer a terse response. 3.27. What is the ratio of the Aid flow (current US$) of Estonia in 1996 to that in 1998?
Make the answer very short. 0.53. What is the ratio of the Aid flow (current US$) in West Bank and Gaza in 1996 to that in 1998?
Offer a terse response. 0.57. What is the ratio of the Aid flow (current US$) in Armenia in 1996 to that in 1999?
Keep it short and to the point. 2.83. What is the ratio of the Aid flow (current US$) in China in 1996 to that in 1999?
Offer a very short reply. 2.1. What is the ratio of the Aid flow (current US$) of Estonia in 1996 to that in 1999?
Your answer should be compact. 1.32. What is the ratio of the Aid flow (current US$) of West Bank and Gaza in 1996 to that in 1999?
Keep it short and to the point. 0.8. What is the ratio of the Aid flow (current US$) in Armenia in 1996 to that in 2000?
Your answer should be very brief. 2.28. What is the ratio of the Aid flow (current US$) in China in 1996 to that in 2000?
Provide a short and direct response. 2.11. What is the ratio of the Aid flow (current US$) of Estonia in 1996 to that in 2000?
Make the answer very short. 0.8. What is the ratio of the Aid flow (current US$) of West Bank and Gaza in 1996 to that in 2000?
Keep it short and to the point. 0.67. What is the ratio of the Aid flow (current US$) in Armenia in 1996 to that in 2001?
Your response must be concise. 1.4. What is the ratio of the Aid flow (current US$) of China in 1996 to that in 2001?
Ensure brevity in your answer.  2.27. What is the ratio of the Aid flow (current US$) of Estonia in 1996 to that in 2001?
Give a very brief answer. 1.06. What is the ratio of the Aid flow (current US$) of West Bank and Gaza in 1996 to that in 2001?
Your answer should be very brief. 0.76. What is the ratio of the Aid flow (current US$) in Armenia in 1996 to that in 2002?
Your answer should be very brief. 1.5. What is the ratio of the Aid flow (current US$) in China in 1996 to that in 2002?
Give a very brief answer. 1.26. What is the ratio of the Aid flow (current US$) of Estonia in 1996 to that in 2002?
Provide a succinct answer. 0.77. What is the ratio of the Aid flow (current US$) in West Bank and Gaza in 1996 to that in 2002?
Your response must be concise. 0.62. What is the ratio of the Aid flow (current US$) of Armenia in 1997 to that in 1998?
Provide a short and direct response. 1.84. What is the ratio of the Aid flow (current US$) of China in 1997 to that in 1998?
Provide a short and direct response. 1.68. What is the ratio of the Aid flow (current US$) in Estonia in 1997 to that in 1998?
Offer a very short reply. 0.55. What is the ratio of the Aid flow (current US$) of West Bank and Gaza in 1997 to that in 1998?
Your response must be concise. 0.76. What is the ratio of the Aid flow (current US$) in Armenia in 1997 to that in 1999?
Ensure brevity in your answer.  2.13. What is the ratio of the Aid flow (current US$) of China in 1997 to that in 1999?
Your answer should be very brief. 1.09. What is the ratio of the Aid flow (current US$) of Estonia in 1997 to that in 1999?
Offer a terse response. 1.36. What is the ratio of the Aid flow (current US$) in West Bank and Gaza in 1997 to that in 1999?
Your response must be concise. 1.06. What is the ratio of the Aid flow (current US$) in Armenia in 1997 to that in 2000?
Make the answer very short. 1.72. What is the ratio of the Aid flow (current US$) of China in 1997 to that in 2000?
Give a very brief answer. 1.09. What is the ratio of the Aid flow (current US$) in Estonia in 1997 to that in 2000?
Your answer should be compact. 0.82. What is the ratio of the Aid flow (current US$) of West Bank and Gaza in 1997 to that in 2000?
Your response must be concise. 0.9. What is the ratio of the Aid flow (current US$) in Armenia in 1997 to that in 2001?
Ensure brevity in your answer.  1.05. What is the ratio of the Aid flow (current US$) in China in 1997 to that in 2001?
Keep it short and to the point. 1.17. What is the ratio of the Aid flow (current US$) in Estonia in 1997 to that in 2001?
Ensure brevity in your answer.  1.1. What is the ratio of the Aid flow (current US$) in West Bank and Gaza in 1997 to that in 2001?
Give a very brief answer. 1.01. What is the ratio of the Aid flow (current US$) of Armenia in 1997 to that in 2002?
Make the answer very short. 1.13. What is the ratio of the Aid flow (current US$) in China in 1997 to that in 2002?
Offer a terse response. 0.65. What is the ratio of the Aid flow (current US$) of Estonia in 1997 to that in 2002?
Your response must be concise. 0.79. What is the ratio of the Aid flow (current US$) in West Bank and Gaza in 1997 to that in 2002?
Your answer should be compact. 0.82. What is the ratio of the Aid flow (current US$) in Armenia in 1998 to that in 1999?
Provide a succinct answer. 1.16. What is the ratio of the Aid flow (current US$) of China in 1998 to that in 1999?
Provide a succinct answer. 0.64. What is the ratio of the Aid flow (current US$) of Estonia in 1998 to that in 1999?
Provide a short and direct response. 2.47. What is the ratio of the Aid flow (current US$) in West Bank and Gaza in 1998 to that in 1999?
Offer a very short reply. 1.39. What is the ratio of the Aid flow (current US$) in Armenia in 1998 to that in 2000?
Offer a very short reply. 0.93. What is the ratio of the Aid flow (current US$) of China in 1998 to that in 2000?
Your answer should be compact. 0.65. What is the ratio of the Aid flow (current US$) in Estonia in 1998 to that in 2000?
Make the answer very short. 1.5. What is the ratio of the Aid flow (current US$) in West Bank and Gaza in 1998 to that in 2000?
Your answer should be very brief. 1.18. What is the ratio of the Aid flow (current US$) of Armenia in 1998 to that in 2001?
Offer a very short reply. 0.57. What is the ratio of the Aid flow (current US$) of China in 1998 to that in 2001?
Offer a terse response. 0.7. What is the ratio of the Aid flow (current US$) in Estonia in 1998 to that in 2001?
Provide a succinct answer. 2. What is the ratio of the Aid flow (current US$) of West Bank and Gaza in 1998 to that in 2001?
Offer a terse response. 1.32. What is the ratio of the Aid flow (current US$) of Armenia in 1998 to that in 2002?
Your answer should be compact. 0.61. What is the ratio of the Aid flow (current US$) of China in 1998 to that in 2002?
Provide a short and direct response. 0.39. What is the ratio of the Aid flow (current US$) in Estonia in 1998 to that in 2002?
Provide a short and direct response. 1.45. What is the ratio of the Aid flow (current US$) of West Bank and Gaza in 1998 to that in 2002?
Provide a short and direct response. 1.07. What is the ratio of the Aid flow (current US$) of Armenia in 1999 to that in 2000?
Your answer should be very brief. 0.81. What is the ratio of the Aid flow (current US$) in China in 1999 to that in 2000?
Keep it short and to the point. 1. What is the ratio of the Aid flow (current US$) of Estonia in 1999 to that in 2000?
Provide a short and direct response. 0.61. What is the ratio of the Aid flow (current US$) in West Bank and Gaza in 1999 to that in 2000?
Offer a terse response. 0.85. What is the ratio of the Aid flow (current US$) in Armenia in 1999 to that in 2001?
Make the answer very short. 0.5. What is the ratio of the Aid flow (current US$) in China in 1999 to that in 2001?
Make the answer very short. 1.08. What is the ratio of the Aid flow (current US$) of Estonia in 1999 to that in 2001?
Offer a terse response. 0.81. What is the ratio of the Aid flow (current US$) of West Bank and Gaza in 1999 to that in 2001?
Provide a short and direct response. 0.95. What is the ratio of the Aid flow (current US$) in Armenia in 1999 to that in 2002?
Make the answer very short. 0.53. What is the ratio of the Aid flow (current US$) in China in 1999 to that in 2002?
Offer a very short reply. 0.6. What is the ratio of the Aid flow (current US$) in Estonia in 1999 to that in 2002?
Keep it short and to the point. 0.58. What is the ratio of the Aid flow (current US$) in West Bank and Gaza in 1999 to that in 2002?
Your response must be concise. 0.77. What is the ratio of the Aid flow (current US$) in Armenia in 2000 to that in 2001?
Provide a succinct answer. 0.61. What is the ratio of the Aid flow (current US$) of China in 2000 to that in 2001?
Offer a very short reply. 1.07. What is the ratio of the Aid flow (current US$) in Estonia in 2000 to that in 2001?
Your answer should be compact. 1.33. What is the ratio of the Aid flow (current US$) in West Bank and Gaza in 2000 to that in 2001?
Provide a short and direct response. 1.12. What is the ratio of the Aid flow (current US$) in Armenia in 2000 to that in 2002?
Your response must be concise. 0.66. What is the ratio of the Aid flow (current US$) in China in 2000 to that in 2002?
Your answer should be very brief. 0.6. What is the ratio of the Aid flow (current US$) in Estonia in 2000 to that in 2002?
Give a very brief answer. 0.96. What is the ratio of the Aid flow (current US$) in West Bank and Gaza in 2000 to that in 2002?
Offer a terse response. 0.91. What is the ratio of the Aid flow (current US$) of Armenia in 2001 to that in 2002?
Keep it short and to the point. 1.07. What is the ratio of the Aid flow (current US$) in China in 2001 to that in 2002?
Ensure brevity in your answer.  0.55. What is the ratio of the Aid flow (current US$) in Estonia in 2001 to that in 2002?
Provide a succinct answer. 0.72. What is the ratio of the Aid flow (current US$) of West Bank and Gaza in 2001 to that in 2002?
Offer a very short reply. 0.81. What is the difference between the highest and the second highest Aid flow (current US$) in Armenia?
Make the answer very short. 1.43e+06. What is the difference between the highest and the second highest Aid flow (current US$) in China?
Offer a terse response. 6.02e+06. What is the difference between the highest and the second highest Aid flow (current US$) of Estonia?
Give a very brief answer. 5.80e+05. What is the difference between the highest and the second highest Aid flow (current US$) of West Bank and Gaza?
Your answer should be compact. 1.12e+06. What is the difference between the highest and the lowest Aid flow (current US$) of Armenia?
Give a very brief answer. 3.76e+06. What is the difference between the highest and the lowest Aid flow (current US$) of China?
Your answer should be very brief. 6.74e+07. What is the difference between the highest and the lowest Aid flow (current US$) in Estonia?
Provide a succinct answer. 1.25e+06. What is the difference between the highest and the lowest Aid flow (current US$) of West Bank and Gaza?
Your answer should be very brief. 1.10e+07. 